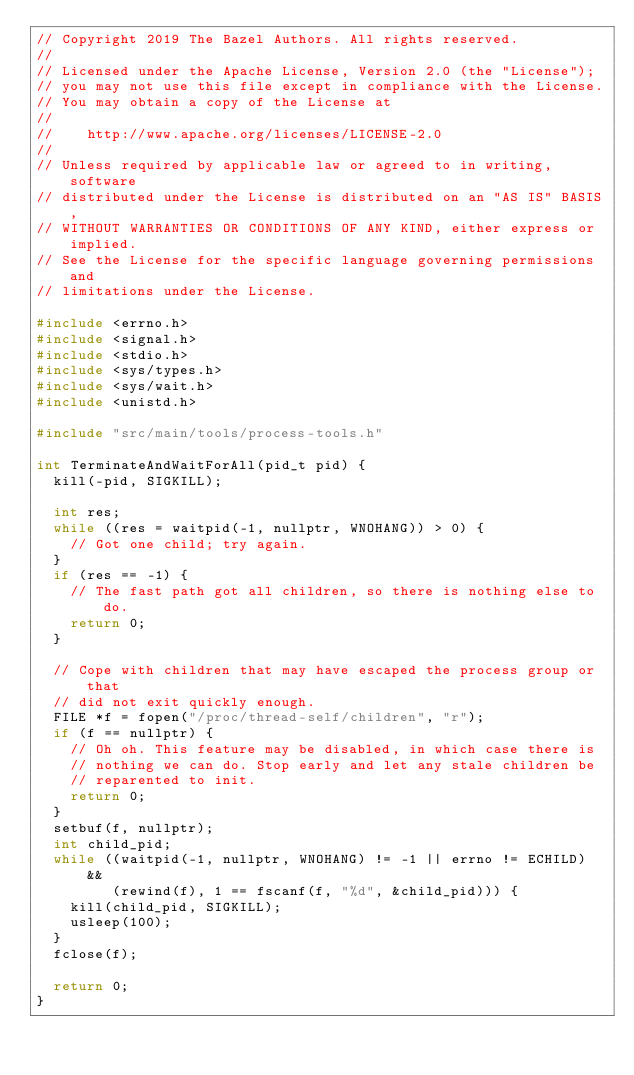<code> <loc_0><loc_0><loc_500><loc_500><_C++_>// Copyright 2019 The Bazel Authors. All rights reserved.
//
// Licensed under the Apache License, Version 2.0 (the "License");
// you may not use this file except in compliance with the License.
// You may obtain a copy of the License at
//
//    http://www.apache.org/licenses/LICENSE-2.0
//
// Unless required by applicable law or agreed to in writing, software
// distributed under the License is distributed on an "AS IS" BASIS,
// WITHOUT WARRANTIES OR CONDITIONS OF ANY KIND, either express or implied.
// See the License for the specific language governing permissions and
// limitations under the License.

#include <errno.h>
#include <signal.h>
#include <stdio.h>
#include <sys/types.h>
#include <sys/wait.h>
#include <unistd.h>

#include "src/main/tools/process-tools.h"

int TerminateAndWaitForAll(pid_t pid) {
  kill(-pid, SIGKILL);

  int res;
  while ((res = waitpid(-1, nullptr, WNOHANG)) > 0) {
    // Got one child; try again.
  }
  if (res == -1) {
    // The fast path got all children, so there is nothing else to do.
    return 0;
  }

  // Cope with children that may have escaped the process group or that
  // did not exit quickly enough.
  FILE *f = fopen("/proc/thread-self/children", "r");
  if (f == nullptr) {
    // Oh oh. This feature may be disabled, in which case there is
    // nothing we can do. Stop early and let any stale children be
    // reparented to init.
    return 0;
  }
  setbuf(f, nullptr);
  int child_pid;
  while ((waitpid(-1, nullptr, WNOHANG) != -1 || errno != ECHILD) &&
         (rewind(f), 1 == fscanf(f, "%d", &child_pid))) {
    kill(child_pid, SIGKILL);
    usleep(100);
  }
  fclose(f);

  return 0;
}
</code> 